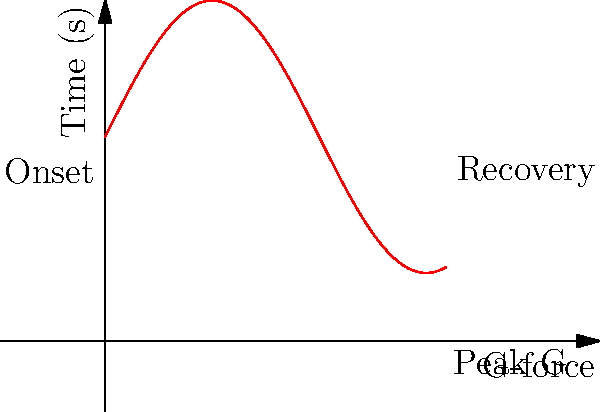Analyze the graph depicting G-force effects during a high-speed maneuver. What is the maximum G-force experienced, and at which phase of the maneuver does it occur? To answer this question, we need to analyze the graph step-by-step:

1. The graph shows G-force on the vertical axis and Time on the horizontal axis.
2. The curve represents the G-force experienced during a high-speed maneuver.
3. The maneuver can be divided into three phases: Onset, Peak, and Recovery.
4. The G-force starts at a baseline (likely 1G) and increases during the Onset phase.
5. The highest point on the curve represents the maximum G-force experienced.
6. This peak occurs at the top of the curve, labeled "Peak G" on the graph.
7. After the peak, the G-force decreases during the Recovery phase.
8. By estimating the value at the highest point, we can see that the maximum G-force is approximately 5G.

Therefore, the maximum G-force experienced is about 5G, and it occurs during the Peak phase of the maneuver.
Answer: 5G during Peak phase 